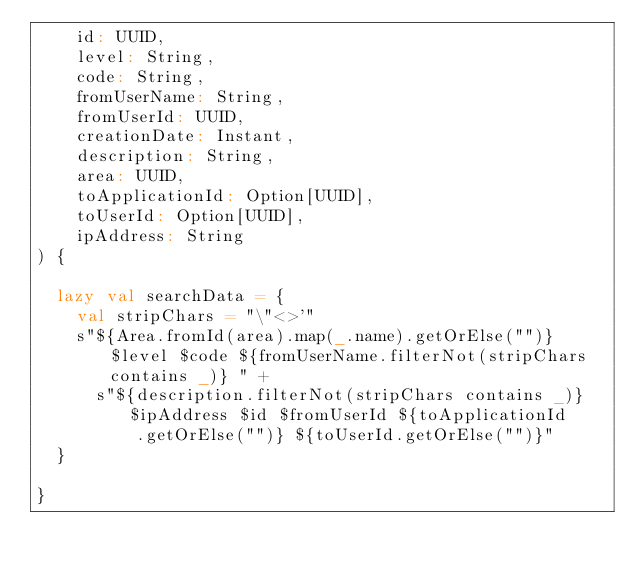Convert code to text. <code><loc_0><loc_0><loc_500><loc_500><_Scala_>    id: UUID,
    level: String,
    code: String,
    fromUserName: String,
    fromUserId: UUID,
    creationDate: Instant,
    description: String,
    area: UUID,
    toApplicationId: Option[UUID],
    toUserId: Option[UUID],
    ipAddress: String
) {

  lazy val searchData = {
    val stripChars = "\"<>'"
    s"${Area.fromId(area).map(_.name).getOrElse("")} $level $code ${fromUserName.filterNot(stripChars contains _)} " +
      s"${description.filterNot(stripChars contains _)} $ipAddress $id $fromUserId ${toApplicationId
          .getOrElse("")} ${toUserId.getOrElse("")}"
  }

}
</code> 